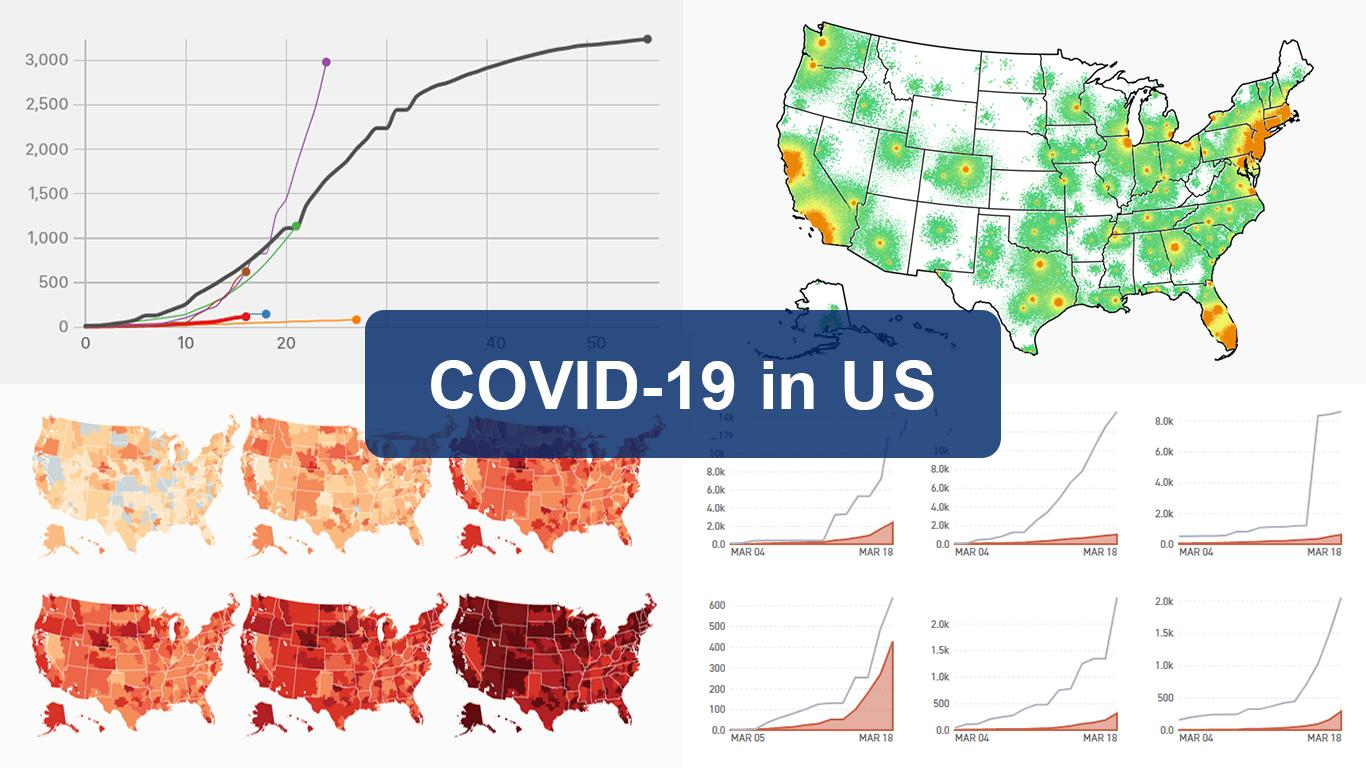Identify some key points in this picture. This infographic features 7 maps. 